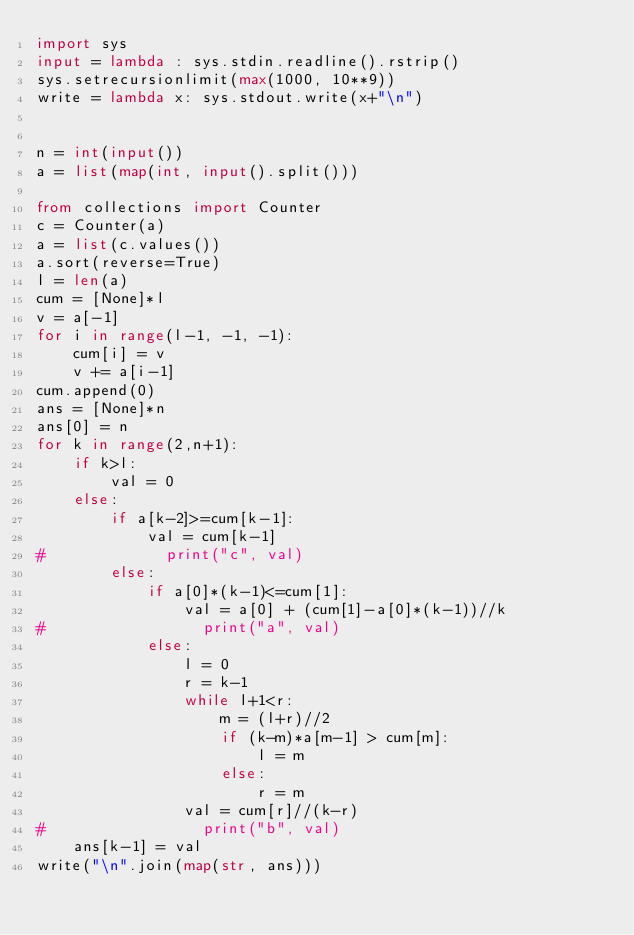Convert code to text. <code><loc_0><loc_0><loc_500><loc_500><_Python_>import sys
input = lambda : sys.stdin.readline().rstrip()
sys.setrecursionlimit(max(1000, 10**9))
write = lambda x: sys.stdout.write(x+"\n")


n = int(input())
a = list(map(int, input().split()))

from collections import Counter
c = Counter(a)
a = list(c.values())
a.sort(reverse=True)
l = len(a)
cum = [None]*l
v = a[-1]
for i in range(l-1, -1, -1):
    cum[i] = v
    v += a[i-1]
cum.append(0)
ans = [None]*n
ans[0] = n
for k in range(2,n+1):
    if k>l:
        val = 0
    else:
        if a[k-2]>=cum[k-1]:
            val = cum[k-1]
#             print("c", val)
        else:
            if a[0]*(k-1)<=cum[1]:
                val = a[0] + (cum[1]-a[0]*(k-1))//k
#                 print("a", val)
            else:
                l = 0
                r = k-1
                while l+1<r:
                    m = (l+r)//2
                    if (k-m)*a[m-1] > cum[m]:
                        l = m
                    else:
                        r = m
                val = cum[r]//(k-r)
#                 print("b", val)
    ans[k-1] = val
write("\n".join(map(str, ans)))</code> 